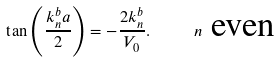Convert formula to latex. <formula><loc_0><loc_0><loc_500><loc_500>\tan \left ( \frac { k _ { n } ^ { b } a } { 2 } \right ) = - \frac { 2 k _ { n } ^ { b } } { V _ { 0 } } . \text {\quad \ } n \text { even}</formula> 